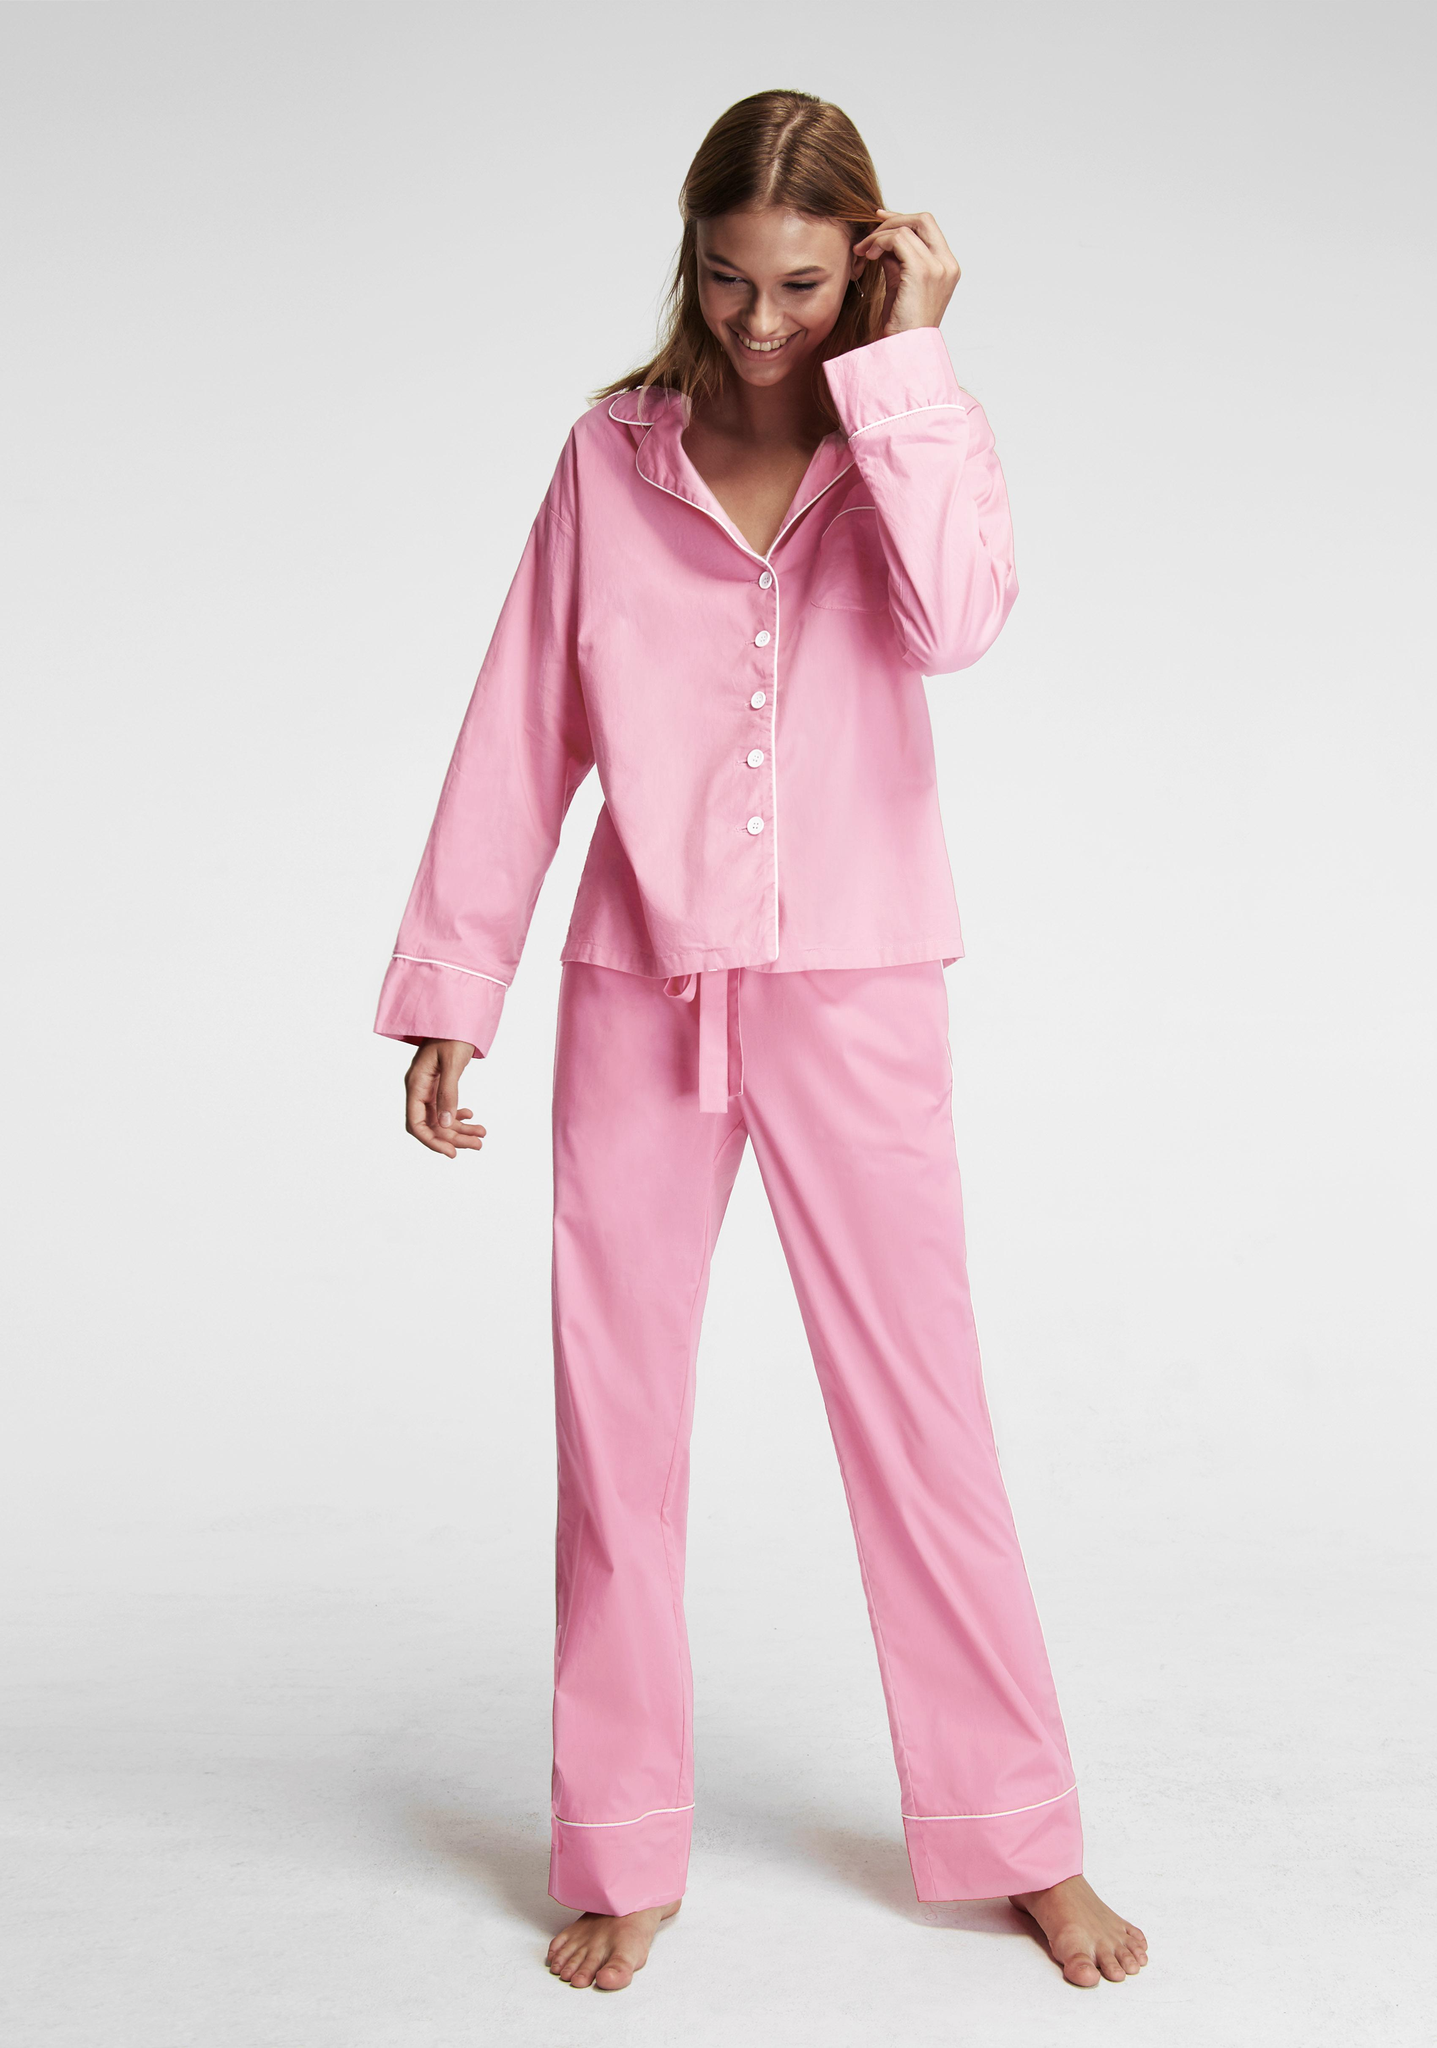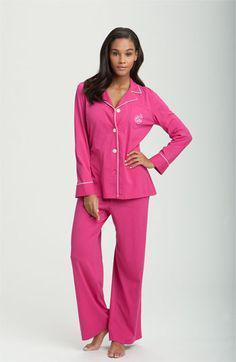The first image is the image on the left, the second image is the image on the right. Evaluate the accuracy of this statement regarding the images: "A woman is wearing a pajama with short sleeves in one of the images.". Is it true? Answer yes or no. No. The first image is the image on the left, the second image is the image on the right. Analyze the images presented: Is the assertion "Exactly one model wears a long sleeved collared button-up top, and exactly one model wears a short sleeve top, but no model wears short shorts." valid? Answer yes or no. No. 